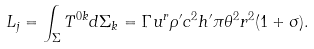<formula> <loc_0><loc_0><loc_500><loc_500>L _ { j } = \int _ { \Sigma } T ^ { 0 k } d \Sigma _ { k } = \Gamma u ^ { r } \rho ^ { \prime } c ^ { 2 } h ^ { \prime } \pi \theta ^ { 2 } r ^ { 2 } ( 1 + \sigma ) .</formula> 